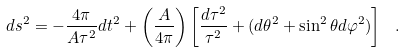<formula> <loc_0><loc_0><loc_500><loc_500>d s ^ { 2 } = - { \frac { 4 \pi } { A \tau ^ { 2 } } } d t ^ { 2 } + \left ( { \frac { A } { 4 \pi } } \right ) \left [ { \frac { d \tau ^ { 2 } } { \tau ^ { 2 } } } + ( d \theta ^ { 2 } + \sin ^ { 2 } \theta d \varphi ^ { 2 } ) \right ] \ .</formula> 